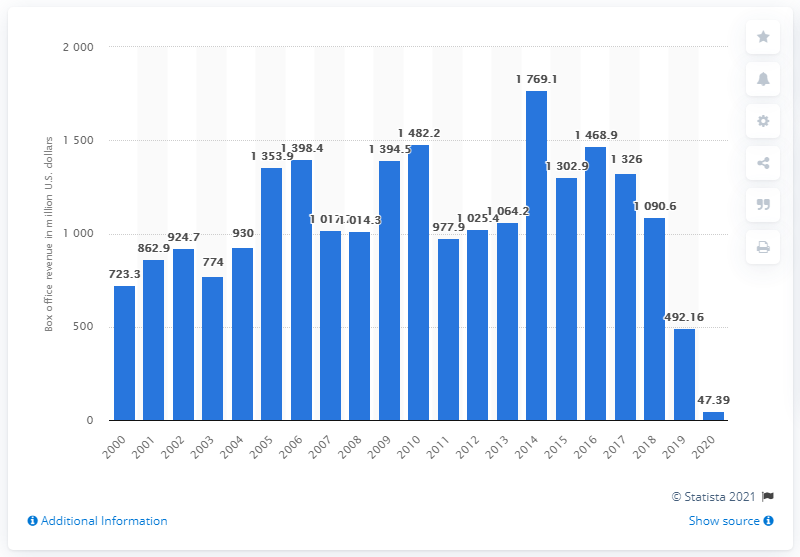Highlight a few significant elements in this photo. In 2014, the box office revenue for the 20th century was $1769.1. 